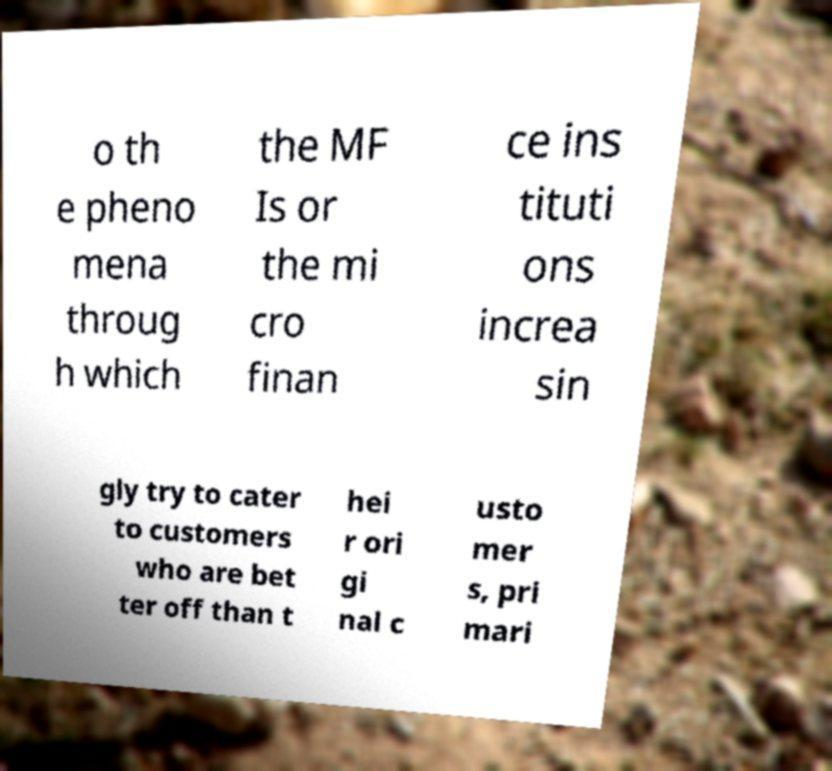Please identify and transcribe the text found in this image. o th e pheno mena throug h which the MF Is or the mi cro finan ce ins tituti ons increa sin gly try to cater to customers who are bet ter off than t hei r ori gi nal c usto mer s, pri mari 